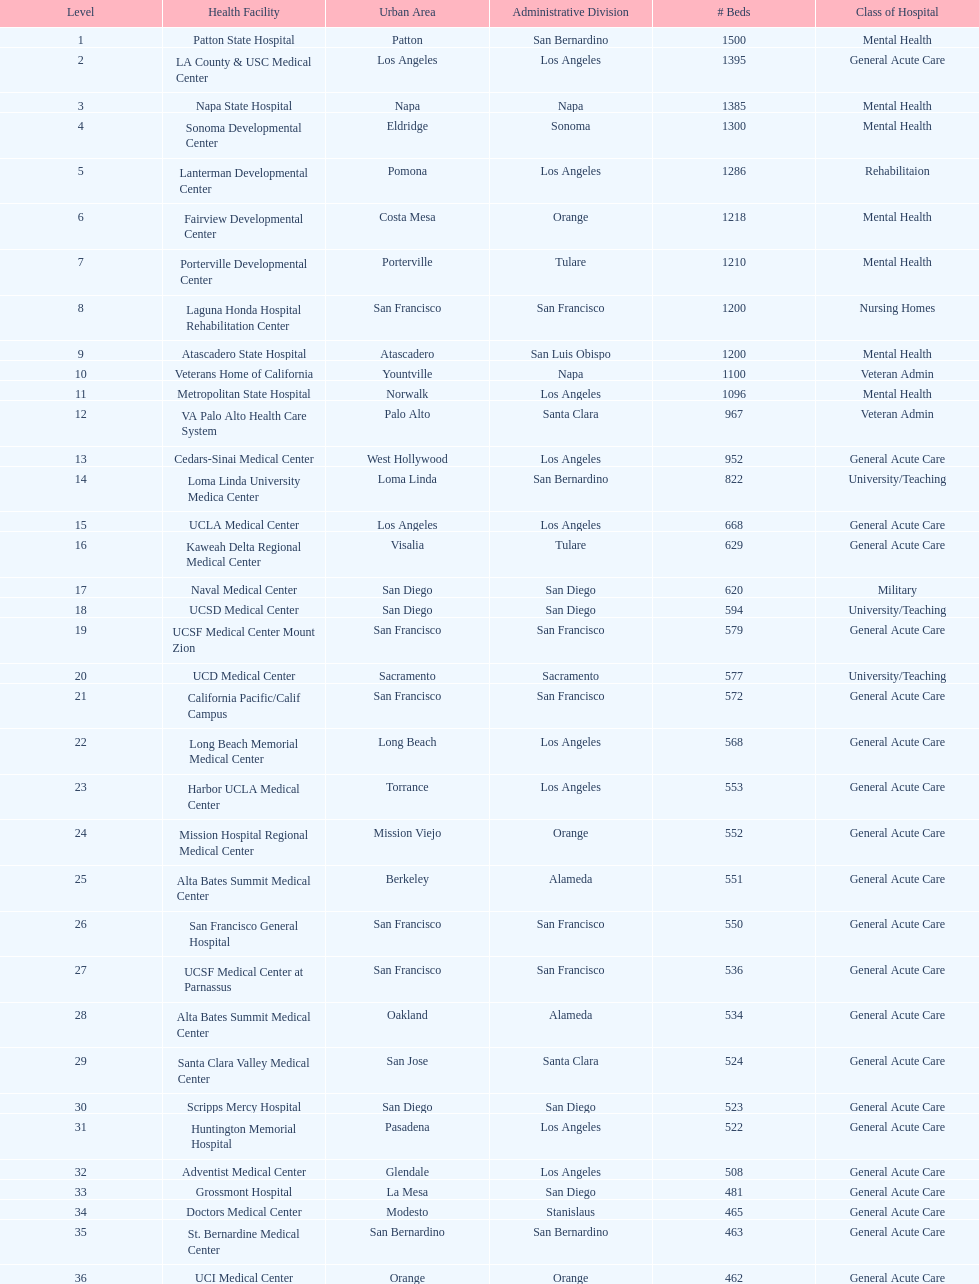Does patton state hospital in the city of patton in san bernardino county have more mental health hospital beds than atascadero state hospital in atascadero, san luis obispo county? Yes. 